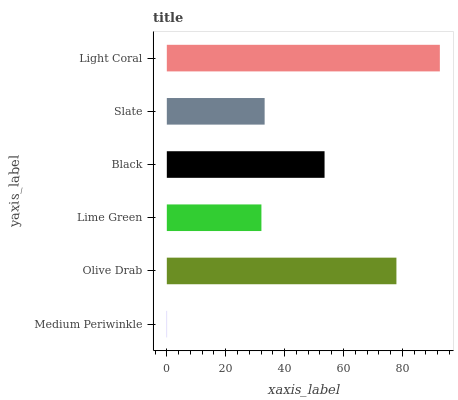Is Medium Periwinkle the minimum?
Answer yes or no. Yes. Is Light Coral the maximum?
Answer yes or no. Yes. Is Olive Drab the minimum?
Answer yes or no. No. Is Olive Drab the maximum?
Answer yes or no. No. Is Olive Drab greater than Medium Periwinkle?
Answer yes or no. Yes. Is Medium Periwinkle less than Olive Drab?
Answer yes or no. Yes. Is Medium Periwinkle greater than Olive Drab?
Answer yes or no. No. Is Olive Drab less than Medium Periwinkle?
Answer yes or no. No. Is Black the high median?
Answer yes or no. Yes. Is Slate the low median?
Answer yes or no. Yes. Is Medium Periwinkle the high median?
Answer yes or no. No. Is Lime Green the low median?
Answer yes or no. No. 